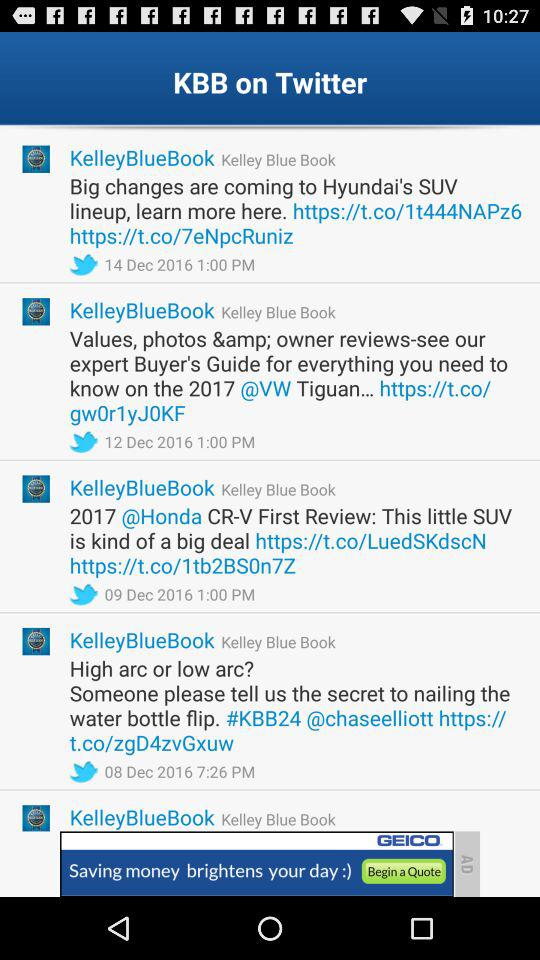How much more does the MSRP cost than the dealer invoice?
Answer the question using a single word or phrase. $1631 